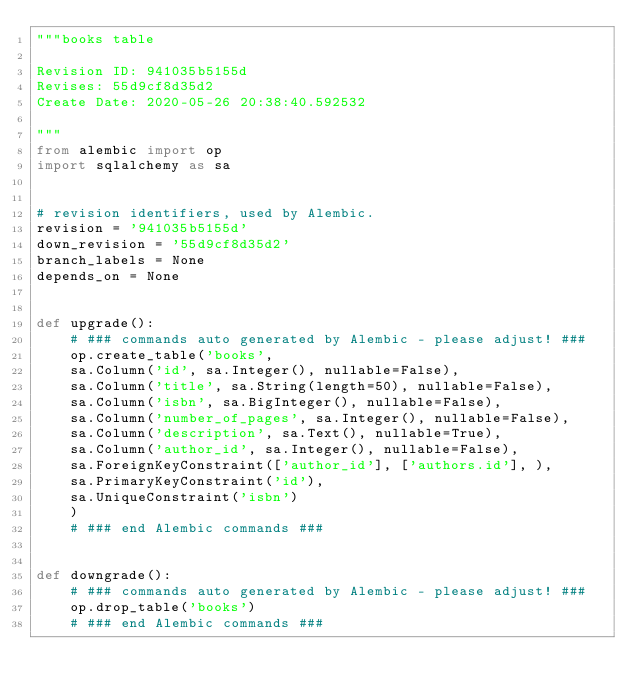<code> <loc_0><loc_0><loc_500><loc_500><_Python_>"""books table

Revision ID: 941035b5155d
Revises: 55d9cf8d35d2
Create Date: 2020-05-26 20:38:40.592532

"""
from alembic import op
import sqlalchemy as sa


# revision identifiers, used by Alembic.
revision = '941035b5155d'
down_revision = '55d9cf8d35d2'
branch_labels = None
depends_on = None


def upgrade():
    # ### commands auto generated by Alembic - please adjust! ###
    op.create_table('books',
    sa.Column('id', sa.Integer(), nullable=False),
    sa.Column('title', sa.String(length=50), nullable=False),
    sa.Column('isbn', sa.BigInteger(), nullable=False),
    sa.Column('number_of_pages', sa.Integer(), nullable=False),
    sa.Column('description', sa.Text(), nullable=True),
    sa.Column('author_id', sa.Integer(), nullable=False),
    sa.ForeignKeyConstraint(['author_id'], ['authors.id'], ),
    sa.PrimaryKeyConstraint('id'),
    sa.UniqueConstraint('isbn')
    )
    # ### end Alembic commands ###


def downgrade():
    # ### commands auto generated by Alembic - please adjust! ###
    op.drop_table('books')
    # ### end Alembic commands ###
</code> 